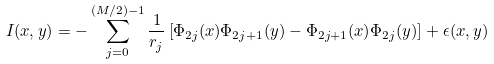<formula> <loc_0><loc_0><loc_500><loc_500>I ( x , y ) = - \sum _ { j = 0 } ^ { ( M / 2 ) - 1 } \frac { 1 } { r _ { j } } \left [ \Phi _ { 2 j } ( x ) \Phi _ { 2 j + 1 } ( y ) - \Phi _ { 2 j + 1 } ( x ) \Phi _ { 2 j } ( y ) \right ] + \epsilon ( x , y )</formula> 